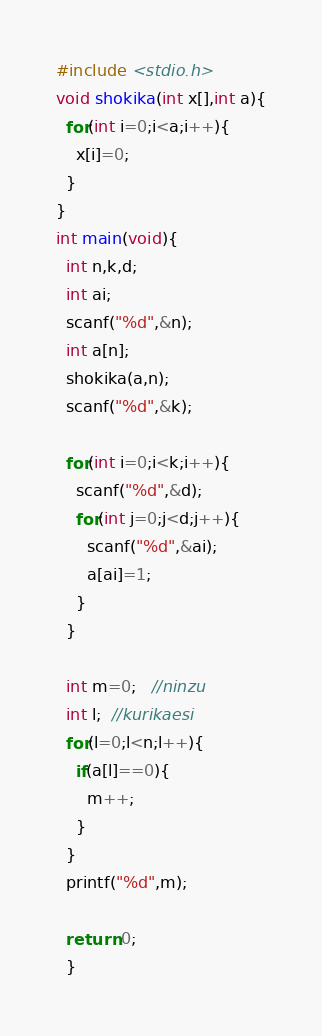<code> <loc_0><loc_0><loc_500><loc_500><_C_>#include <stdio.h>
void shokika(int x[],int a){
  for(int i=0;i<a;i++){
    x[i]=0;
  }
}
int main(void){
  int n,k,d;
  int ai;
  scanf("%d",&n);
  int a[n];
  shokika(a,n);
  scanf("%d",&k);
  
  for(int i=0;i<k;i++){
    scanf("%d",&d);
    for(int j=0;j<d;j++){
      scanf("%d",&ai);
      a[ai]=1;
    }
  }

  int m=0;   //ninzu
  int l;  //kurikaesi
  for(l=0;l<n;l++){
    if(a[l]==0){
      m++;
    }
  }
  printf("%d",m);

  return 0;
  }</code> 